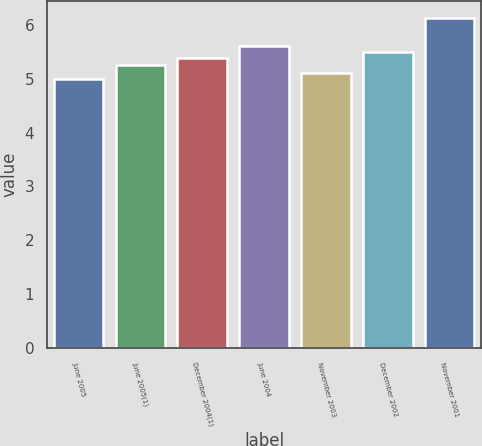<chart> <loc_0><loc_0><loc_500><loc_500><bar_chart><fcel>June 2005<fcel>June 2005(1)<fcel>December 2004(1)<fcel>June 2004<fcel>November 2003<fcel>December 2002<fcel>November 2001<nl><fcel>5<fcel>5.25<fcel>5.38<fcel>5.6<fcel>5.11<fcel>5.49<fcel>6.13<nl></chart> 